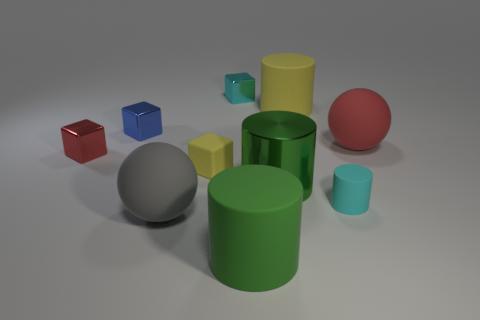There is a block that is the same color as the tiny matte cylinder; what is it made of?
Keep it short and to the point. Metal. What is the material of the cylinder that is on the left side of the large green metal cylinder?
Make the answer very short. Rubber. There is a green object that is the same size as the green rubber cylinder; what is its material?
Offer a terse response. Metal. What is the material of the cylinder behind the blue metallic cube in front of the cube that is behind the small blue shiny thing?
Your response must be concise. Rubber. There is a cylinder that is behind the blue thing; is it the same size as the blue metallic object?
Offer a very short reply. No. There is a block on the right side of the tiny yellow rubber cube; is it the same color as the tiny rubber cylinder?
Give a very brief answer. Yes. Do the big green cylinder behind the cyan rubber thing and the tiny yellow block have the same material?
Your answer should be compact. No. There is a tiny cyan thing that is to the right of the big yellow rubber object that is behind the red rubber sphere; what number of yellow rubber objects are to the left of it?
Your answer should be very brief. 2. Does the yellow matte thing that is to the right of the cyan block have the same shape as the blue thing?
Provide a succinct answer. No. Is there a green shiny object behind the matte cylinder behind the big green metal thing?
Provide a short and direct response. No. 